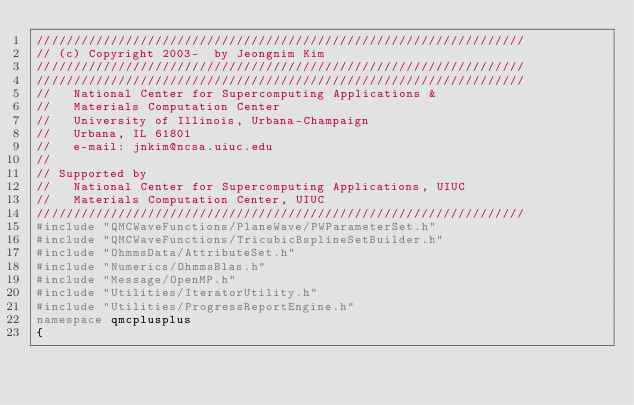Convert code to text. <code><loc_0><loc_0><loc_500><loc_500><_C++_>//////////////////////////////////////////////////////////////////
// (c) Copyright 2003-  by Jeongnim Kim
//////////////////////////////////////////////////////////////////
//////////////////////////////////////////////////////////////////
//   National Center for Supercomputing Applications &
//   Materials Computation Center
//   University of Illinois, Urbana-Champaign
//   Urbana, IL 61801
//   e-mail: jnkim@ncsa.uiuc.edu
//
// Supported by
//   National Center for Supercomputing Applications, UIUC
//   Materials Computation Center, UIUC
//////////////////////////////////////////////////////////////////
#include "QMCWaveFunctions/PlaneWave/PWParameterSet.h"
#include "QMCWaveFunctions/TricubicBsplineSetBuilder.h"
#include "OhmmsData/AttributeSet.h"
#include "Numerics/OhmmsBlas.h"
#include "Message/OpenMP.h"
#include "Utilities/IteratorUtility.h"
#include "Utilities/ProgressReportEngine.h"
namespace qmcplusplus
{
</code> 